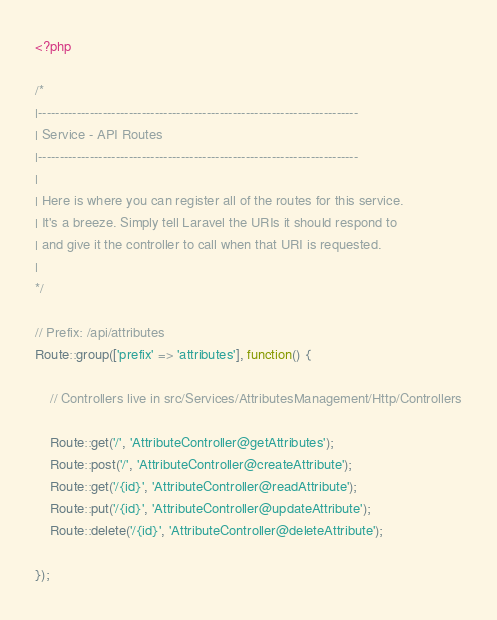<code> <loc_0><loc_0><loc_500><loc_500><_PHP_><?php

/*
|--------------------------------------------------------------------------
| Service - API Routes
|--------------------------------------------------------------------------
|
| Here is where you can register all of the routes for this service.
| It's a breeze. Simply tell Laravel the URIs it should respond to
| and give it the controller to call when that URI is requested.
|
*/

// Prefix: /api/attributes
Route::group(['prefix' => 'attributes'], function() {

    // Controllers live in src/Services/AttributesManagement/Http/Controllers

    Route::get('/', 'AttributeController@getAttributes');
    Route::post('/', 'AttributeController@createAttribute');
    Route::get('/{id}', 'AttributeController@readAttribute');
    Route::put('/{id}', 'AttributeController@updateAttribute');
    Route::delete('/{id}', 'AttributeController@deleteAttribute');

});
</code> 